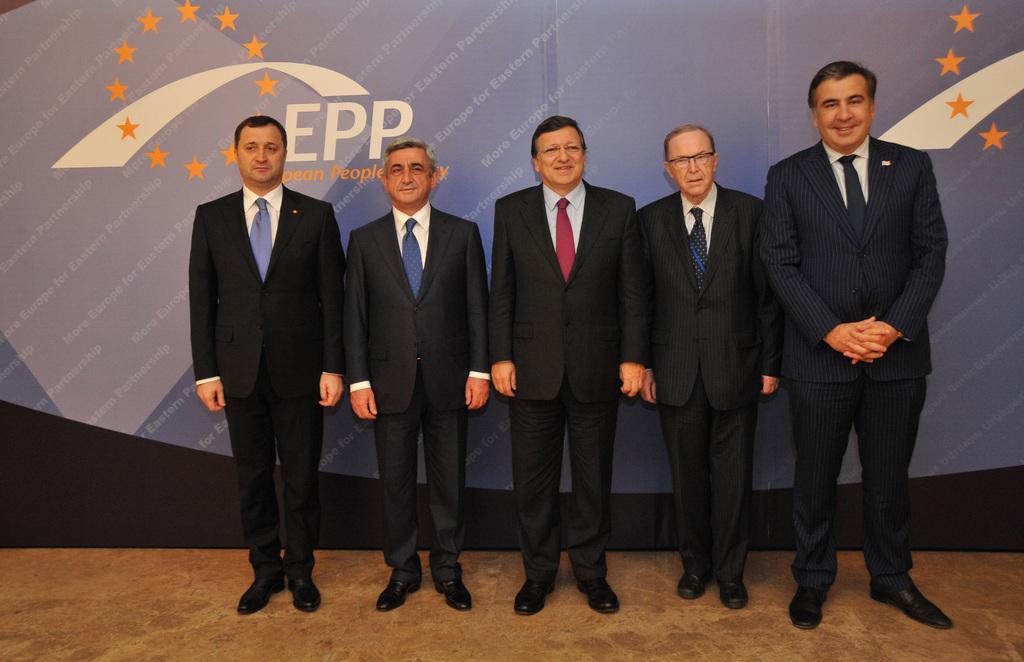Please provide a concise description of this image. In this image we can see five men are standing on the floor. They are wearing suits. Behind them, there is a banner which is in blue color. 